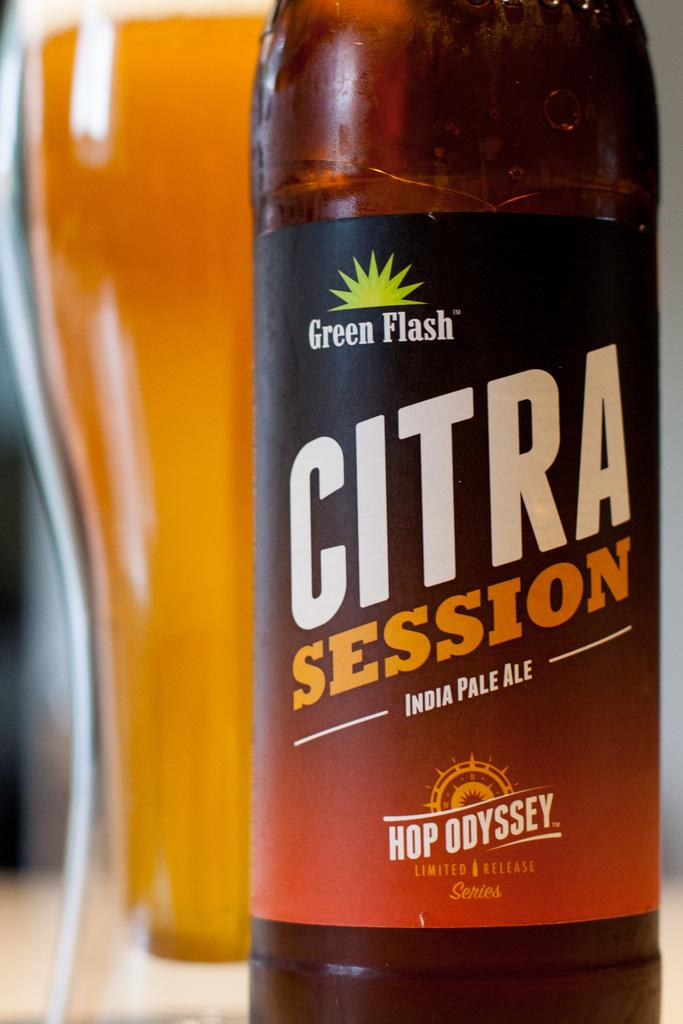<image>
Share a concise interpretation of the image provided. A full glass of beer is next to a bottle of Citra Session. 